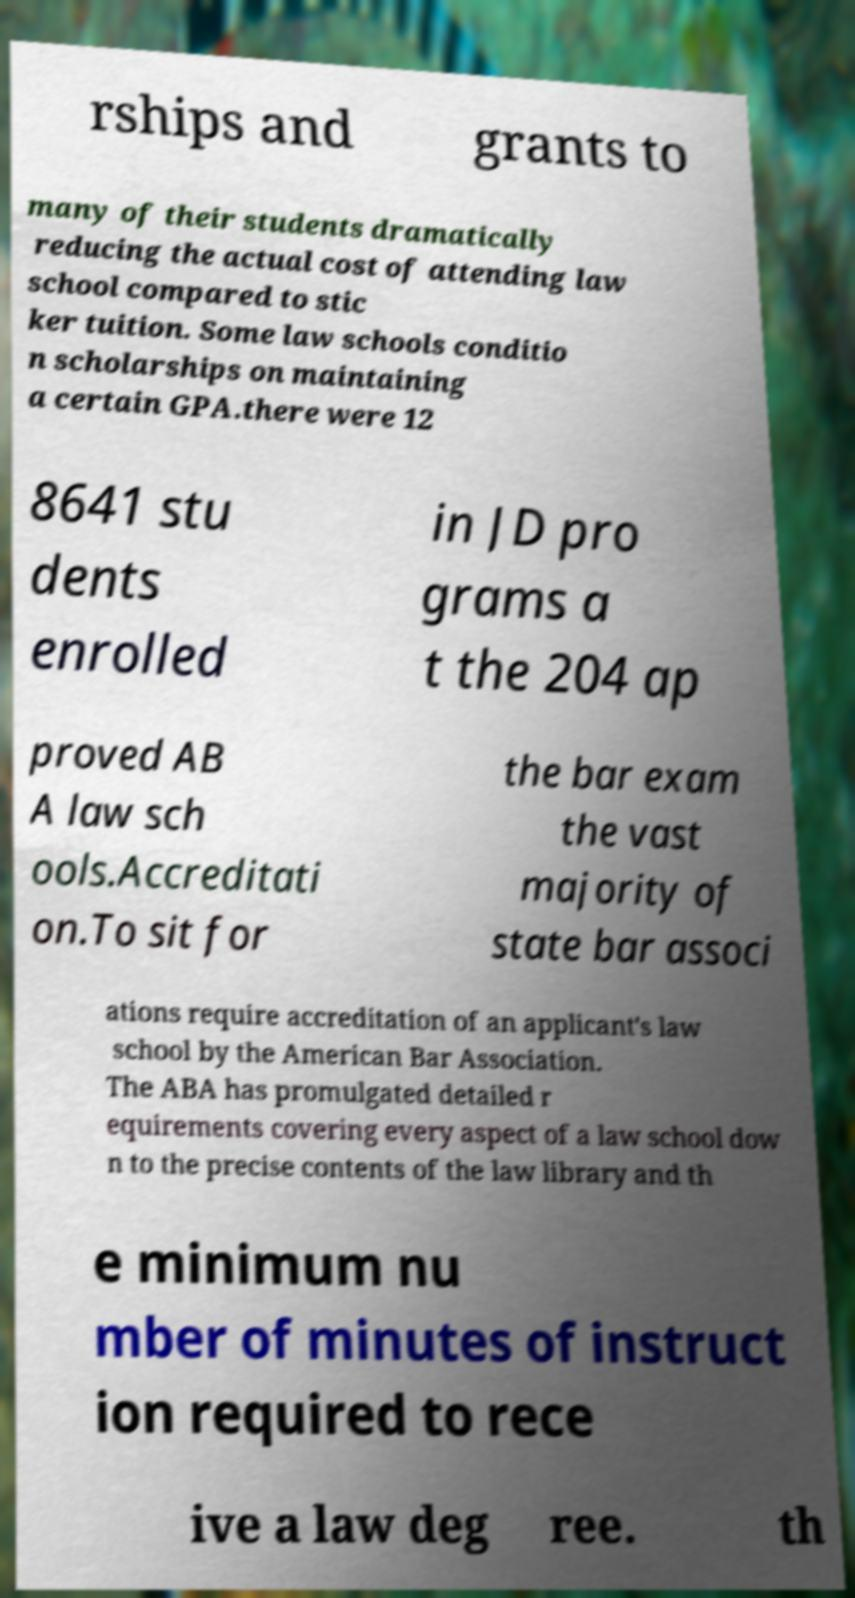Could you extract and type out the text from this image? rships and grants to many of their students dramatically reducing the actual cost of attending law school compared to stic ker tuition. Some law schools conditio n scholarships on maintaining a certain GPA.there were 12 8641 stu dents enrolled in JD pro grams a t the 204 ap proved AB A law sch ools.Accreditati on.To sit for the bar exam the vast majority of state bar associ ations require accreditation of an applicant's law school by the American Bar Association. The ABA has promulgated detailed r equirements covering every aspect of a law school dow n to the precise contents of the law library and th e minimum nu mber of minutes of instruct ion required to rece ive a law deg ree. th 